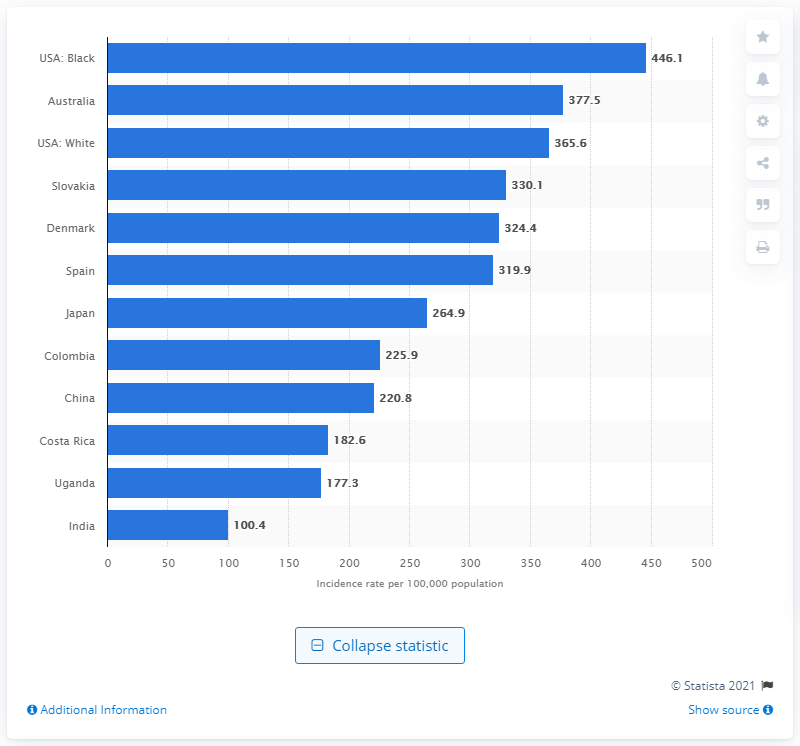Mention a couple of crucial points in this snapshot. According to the data provided, there are approximately 446.1 new cancer cases per 100,000 inhabitants. 